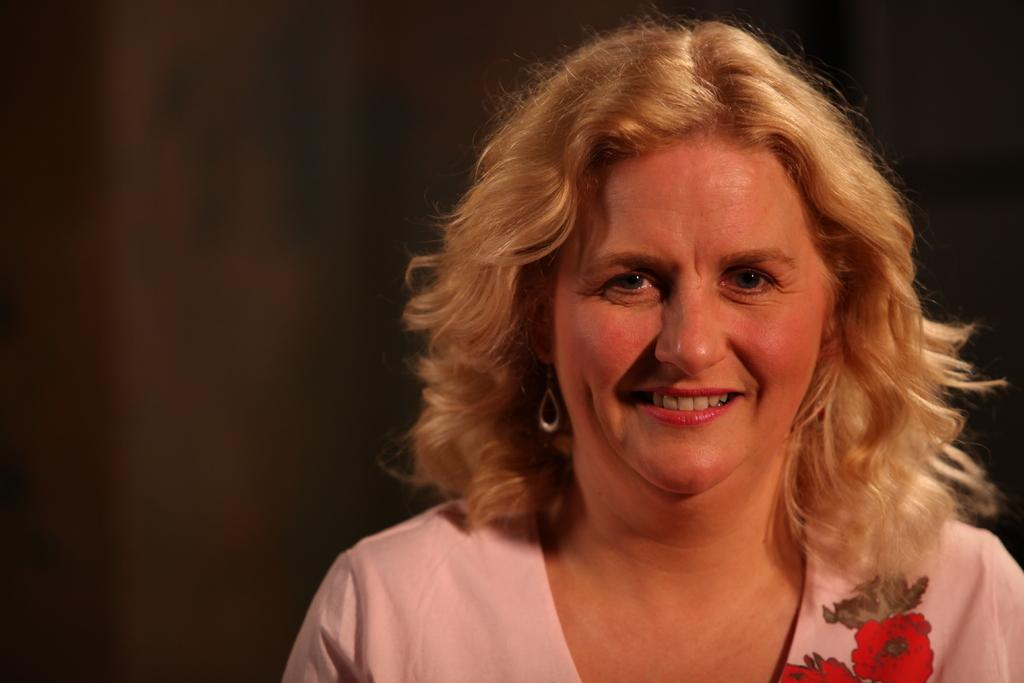Who is the main subject in the picture? There is a woman in the picture. What is the woman doing in the image? The woman is smiling. Can you describe the background of the image? The background of the image is dark. Who is the owner of the boot in the image? There is no boot present in the image. What type of hammer is the woman holding in the image? There is no hammer present in the image. 